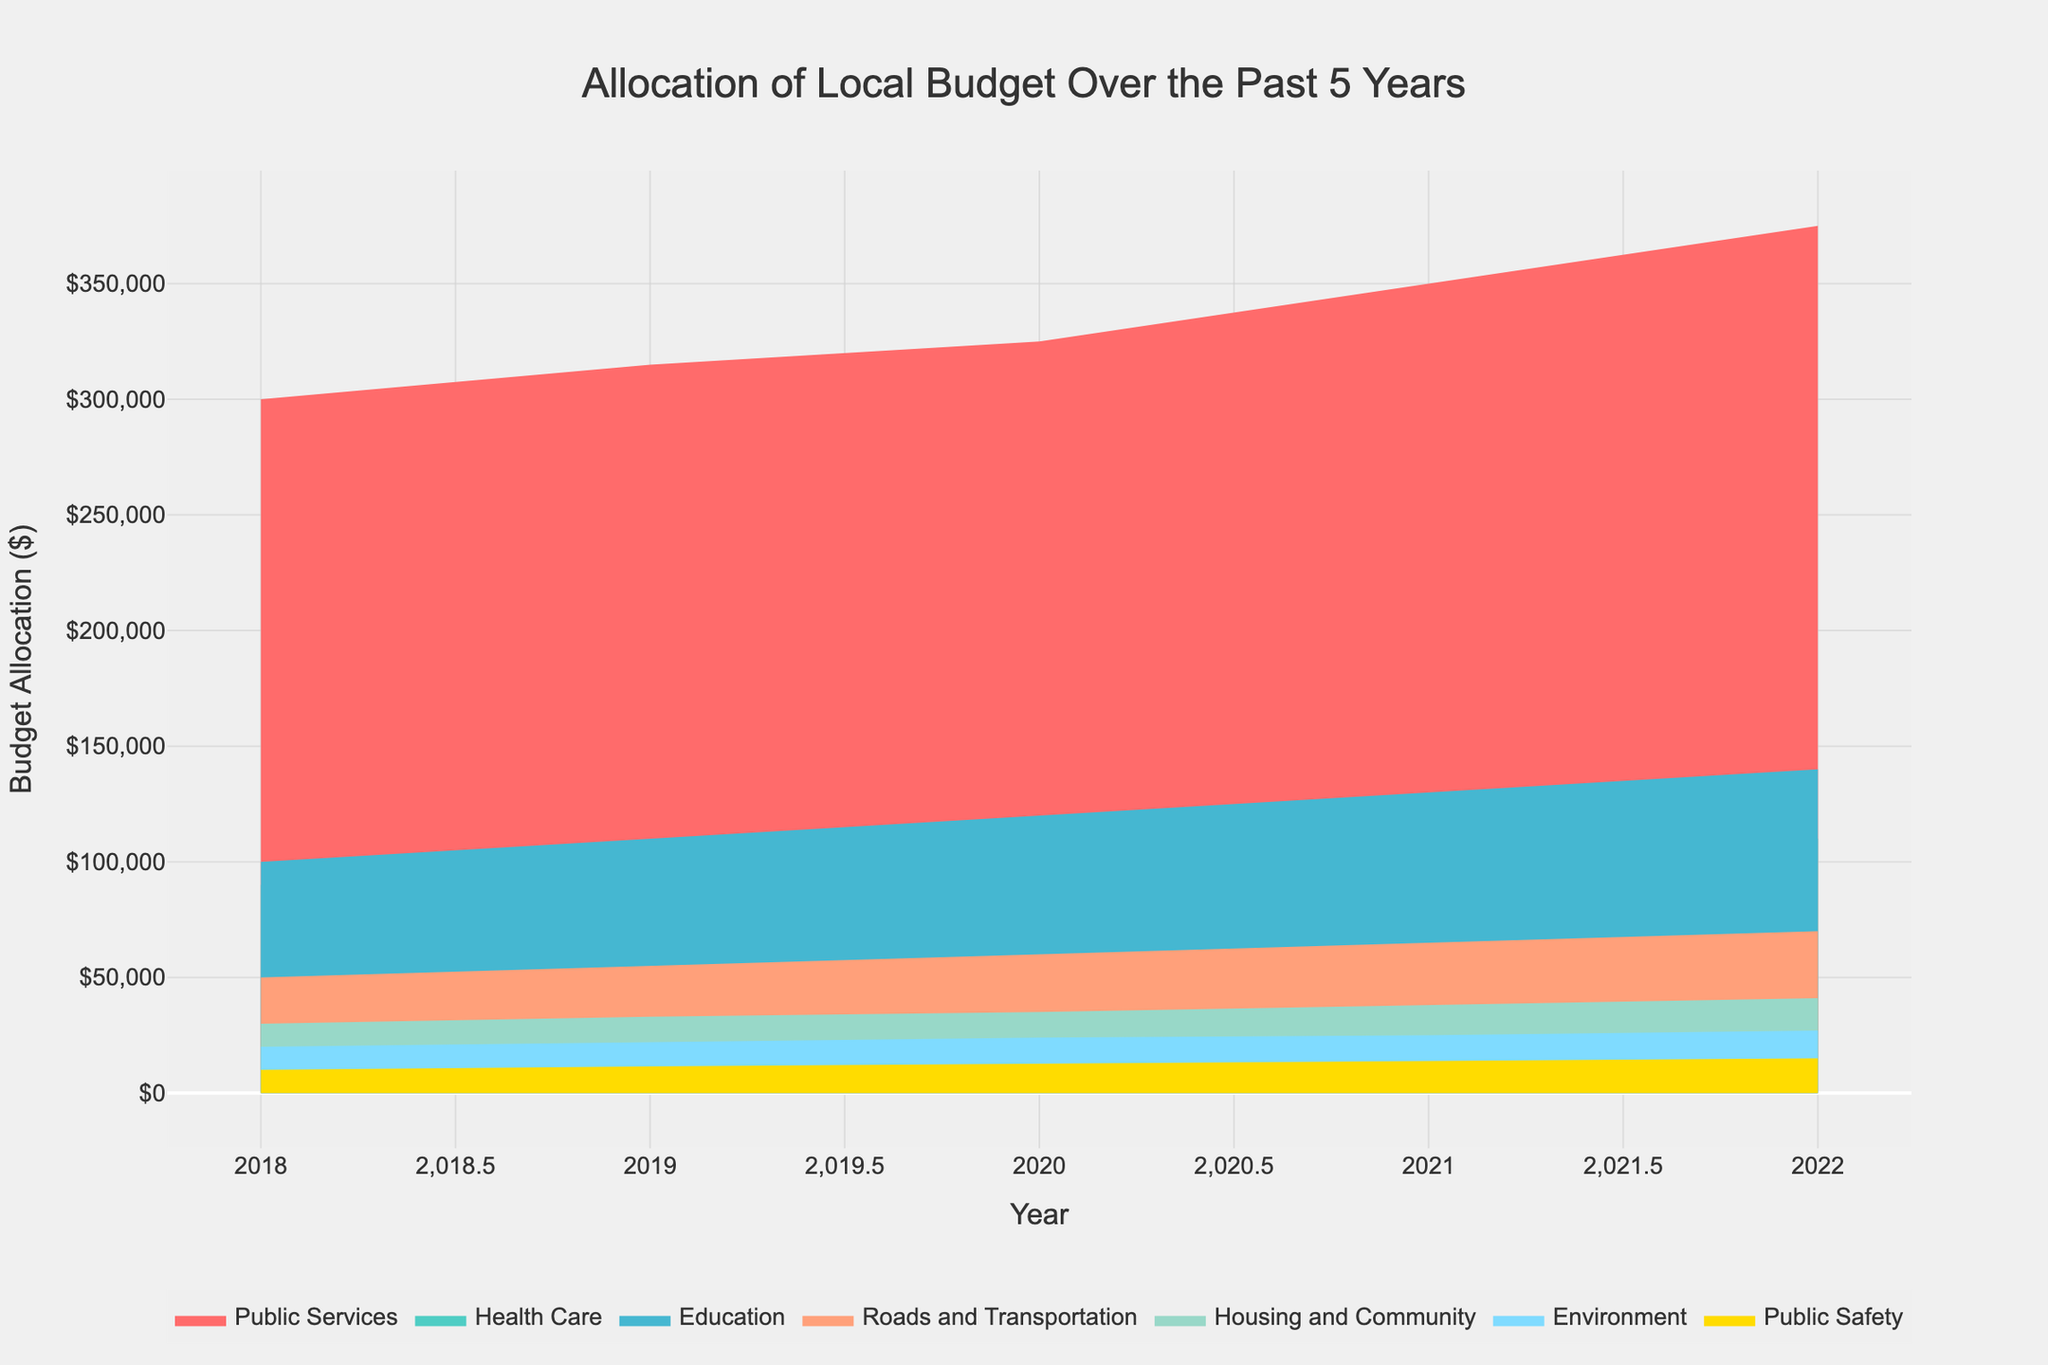What is the highest amount allocated to Public Services over the past 5 years? Looking at the filled area representing Public Services in the plot, the allocation amount is at its highest in the year 2022, which is around $375,000.
Answer: $375,000 How much did the budget for Roads and Transportation increase from 2018 to 2022? The budget for Roads and Transportation in 2018 was $50,000 and in 2022 it was $70,000. The increase is $70,000 - $50,000 = $20,000.
Answer: $20,000 Which category saw the biggest increase in budget allocation between 2018 and 2022? We compare the allocations of each category between 2018 and 2022. Public Services increased from $300,000 to $375,000, which is an increase of $75,000, the highest among all categories.
Answer: Public Services What is the total budget allocated to Health Care over the 5 years? Summing up the allocations to Health Care from 2018 to 2022, we get $90,000 + $94,500 + $100,000 + $105,000 + $110,000. Therefore, $499,500.
Answer: $499,500 Which category has the least allocation in the year 2021? Referring to the plot for the year 2021, Public Safety appears to have the least allocation with around $14,000 allocated.
Answer: Public Safety What was the average annual budget for Environment from 2018 to 2022? Summing the annual allocations to Environment, $20,000 + $22,000 + $24,000 + $25,000 + $27,000 gives $118,000. Dividing by 5 (the number of years), we get $118,000 / 5 = $23,600.
Answer: $23,600 How does the Education budget in 2021 compare to the Health Care budget in 2018? The Education budget in 2021 is $130,000 and the Health Care budget in 2018 is $90,000. So, $130,000 is greater than $90,000.
Answer: $130,000 > $90,000 What is the percentage increase in the total budget from 2018 to 2022? The total budget in 2018 was $1,000,000, and in 2022 it was $1,215,000. The percentage increase is (($1,215,000 - $1,000,000) / $1,000,000) * 100% = 21.5%.
Answer: 21.5% Which category had the steadiest increase over the years? Looking at the filled areas, Health Care shows a consistent year-over-year increase without any significant fluctuations.
Answer: Health Care 